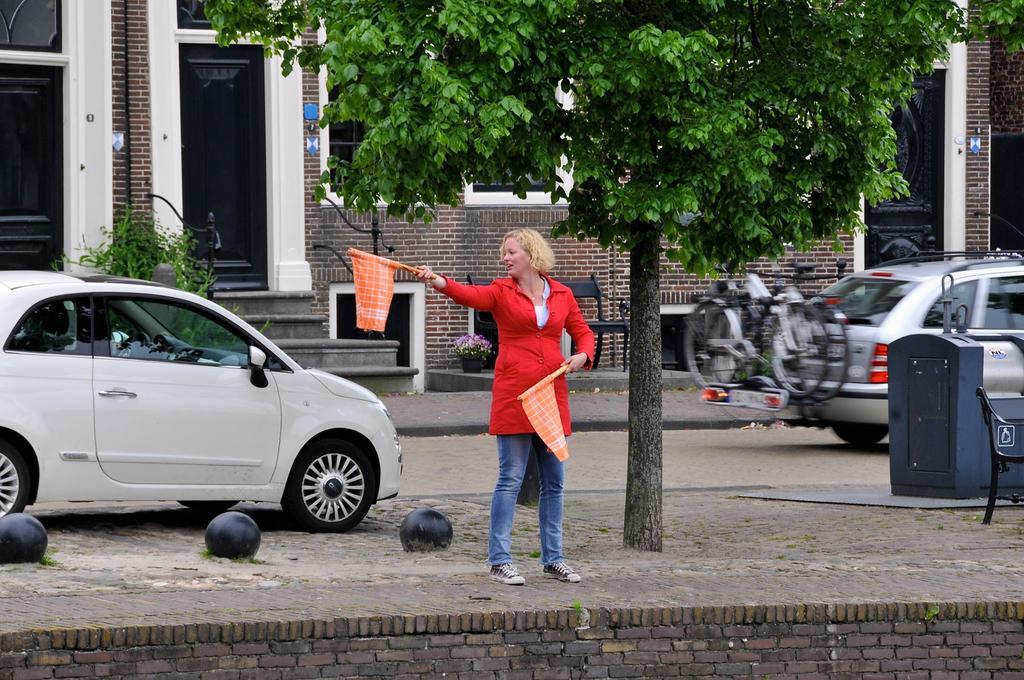Can you describe this image briefly? In this image in the center there is a woman standing and holding flags, there are objects which are black in colour on the ground. There is a tree and there is an empty chair and there is an object which is blue in colour and there are cars. In the background there are bicycles and there is a building and there are empty chairs, there is a plant, there are flowers and there are doors. 